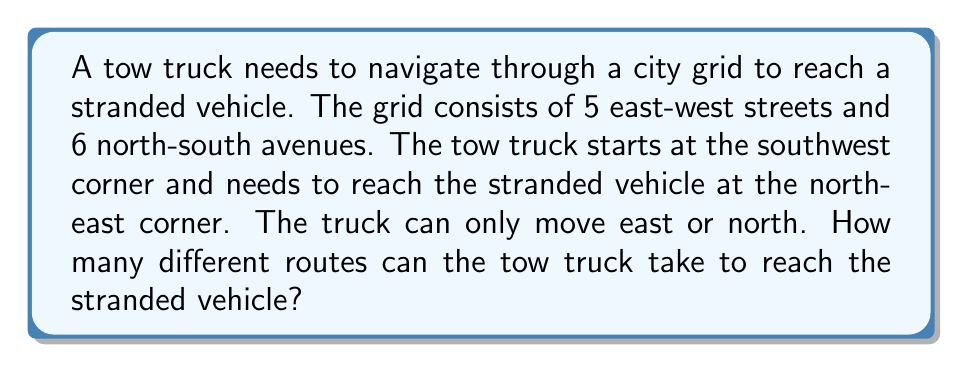Give your solution to this math problem. Let's approach this step-by-step:

1) First, we need to understand what the question is asking. We're looking for the number of paths from one corner of a grid to the opposite corner, moving only right or up.

2) This is a classic combinatorics problem that can be solved using the concept of combinations.

3) To reach the destination, the truck must move:
   - 5 blocks east
   - 4 blocks north

4) The total number of moves is therefore 5 + 4 = 9 moves.

5) The question is essentially asking: in how many ways can we arrange 5 east moves and 4 north moves?

6) This is equivalent to choosing the positions for either the east moves or the north moves out of the total 9 moves.

7) We can solve this using the combination formula:

   $$\binom{9}{5} = \binom{9}{4}$$

8) This can be calculated as:

   $$\binom{9}{5} = \frac{9!}{5!(9-5)!} = \frac{9!}{5!4!}$$

9) Expanding this:

   $$\frac{9 \times 8 \times 7 \times 6 \times 5!}{5! \times 4 \times 3 \times 2 \times 1}$$

10) The 5! cancels out in the numerator and denominator:

    $$\frac{9 \times 8 \times 7 \times 6}{4 \times 3 \times 2 \times 1} = 126$$

Therefore, there are 126 different routes the tow truck can take.
Answer: 126 